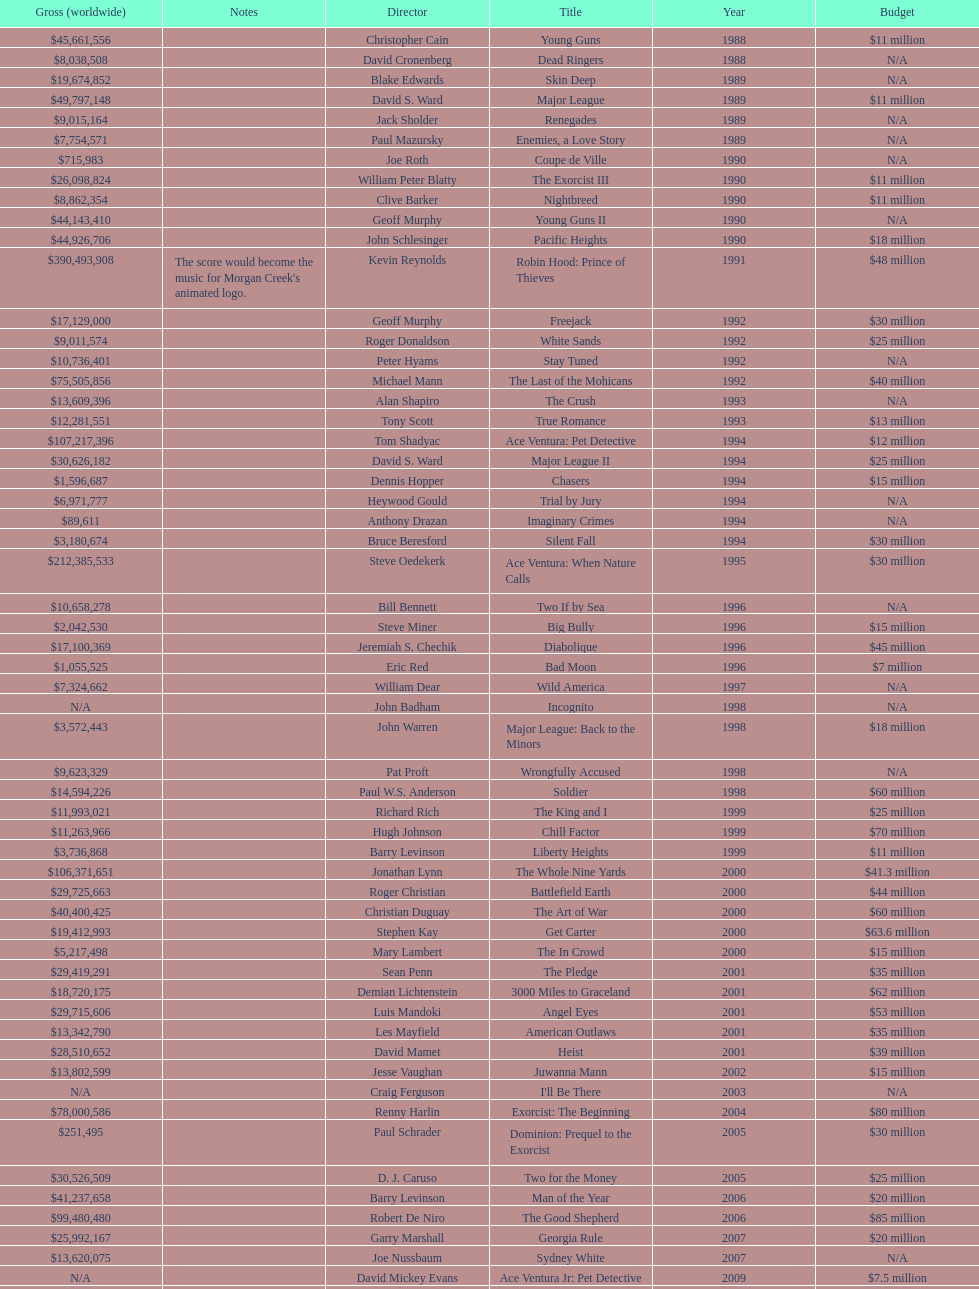Would you be able to parse every entry in this table? {'header': ['Gross (worldwide)', 'Notes', 'Director', 'Title', 'Year', 'Budget'], 'rows': [['$45,661,556', '', 'Christopher Cain', 'Young Guns', '1988', '$11 million'], ['$8,038,508', '', 'David Cronenberg', 'Dead Ringers', '1988', 'N/A'], ['$19,674,852', '', 'Blake Edwards', 'Skin Deep', '1989', 'N/A'], ['$49,797,148', '', 'David S. Ward', 'Major League', '1989', '$11 million'], ['$9,015,164', '', 'Jack Sholder', 'Renegades', '1989', 'N/A'], ['$7,754,571', '', 'Paul Mazursky', 'Enemies, a Love Story', '1989', 'N/A'], ['$715,983', '', 'Joe Roth', 'Coupe de Ville', '1990', 'N/A'], ['$26,098,824', '', 'William Peter Blatty', 'The Exorcist III', '1990', '$11 million'], ['$8,862,354', '', 'Clive Barker', 'Nightbreed', '1990', '$11 million'], ['$44,143,410', '', 'Geoff Murphy', 'Young Guns II', '1990', 'N/A'], ['$44,926,706', '', 'John Schlesinger', 'Pacific Heights', '1990', '$18 million'], ['$390,493,908', "The score would become the music for Morgan Creek's animated logo.", 'Kevin Reynolds', 'Robin Hood: Prince of Thieves', '1991', '$48 million'], ['$17,129,000', '', 'Geoff Murphy', 'Freejack', '1992', '$30 million'], ['$9,011,574', '', 'Roger Donaldson', 'White Sands', '1992', '$25 million'], ['$10,736,401', '', 'Peter Hyams', 'Stay Tuned', '1992', 'N/A'], ['$75,505,856', '', 'Michael Mann', 'The Last of the Mohicans', '1992', '$40 million'], ['$13,609,396', '', 'Alan Shapiro', 'The Crush', '1993', 'N/A'], ['$12,281,551', '', 'Tony Scott', 'True Romance', '1993', '$13 million'], ['$107,217,396', '', 'Tom Shadyac', 'Ace Ventura: Pet Detective', '1994', '$12 million'], ['$30,626,182', '', 'David S. Ward', 'Major League II', '1994', '$25 million'], ['$1,596,687', '', 'Dennis Hopper', 'Chasers', '1994', '$15 million'], ['$6,971,777', '', 'Heywood Gould', 'Trial by Jury', '1994', 'N/A'], ['$89,611', '', 'Anthony Drazan', 'Imaginary Crimes', '1994', 'N/A'], ['$3,180,674', '', 'Bruce Beresford', 'Silent Fall', '1994', '$30 million'], ['$212,385,533', '', 'Steve Oedekerk', 'Ace Ventura: When Nature Calls', '1995', '$30 million'], ['$10,658,278', '', 'Bill Bennett', 'Two If by Sea', '1996', 'N/A'], ['$2,042,530', '', 'Steve Miner', 'Big Bully', '1996', '$15 million'], ['$17,100,369', '', 'Jeremiah S. Chechik', 'Diabolique', '1996', '$45 million'], ['$1,055,525', '', 'Eric Red', 'Bad Moon', '1996', '$7 million'], ['$7,324,662', '', 'William Dear', 'Wild America', '1997', 'N/A'], ['N/A', '', 'John Badham', 'Incognito', '1998', 'N/A'], ['$3,572,443', '', 'John Warren', 'Major League: Back to the Minors', '1998', '$18 million'], ['$9,623,329', '', 'Pat Proft', 'Wrongfully Accused', '1998', 'N/A'], ['$14,594,226', '', 'Paul W.S. Anderson', 'Soldier', '1998', '$60 million'], ['$11,993,021', '', 'Richard Rich', 'The King and I', '1999', '$25 million'], ['$11,263,966', '', 'Hugh Johnson', 'Chill Factor', '1999', '$70 million'], ['$3,736,868', '', 'Barry Levinson', 'Liberty Heights', '1999', '$11 million'], ['$106,371,651', '', 'Jonathan Lynn', 'The Whole Nine Yards', '2000', '$41.3 million'], ['$29,725,663', '', 'Roger Christian', 'Battlefield Earth', '2000', '$44 million'], ['$40,400,425', '', 'Christian Duguay', 'The Art of War', '2000', '$60 million'], ['$19,412,993', '', 'Stephen Kay', 'Get Carter', '2000', '$63.6 million'], ['$5,217,498', '', 'Mary Lambert', 'The In Crowd', '2000', '$15 million'], ['$29,419,291', '', 'Sean Penn', 'The Pledge', '2001', '$35 million'], ['$18,720,175', '', 'Demian Lichtenstein', '3000 Miles to Graceland', '2001', '$62 million'], ['$29,715,606', '', 'Luis Mandoki', 'Angel Eyes', '2001', '$53 million'], ['$13,342,790', '', 'Les Mayfield', 'American Outlaws', '2001', '$35 million'], ['$28,510,652', '', 'David Mamet', 'Heist', '2001', '$39 million'], ['$13,802,599', '', 'Jesse Vaughan', 'Juwanna Mann', '2002', '$15 million'], ['N/A', '', 'Craig Ferguson', "I'll Be There", '2003', 'N/A'], ['$78,000,586', '', 'Renny Harlin', 'Exorcist: The Beginning', '2004', '$80 million'], ['$251,495', '', 'Paul Schrader', 'Dominion: Prequel to the Exorcist', '2005', '$30 million'], ['$30,526,509', '', 'D. J. Caruso', 'Two for the Money', '2005', '$25 million'], ['$41,237,658', '', 'Barry Levinson', 'Man of the Year', '2006', '$20 million'], ['$99,480,480', '', 'Robert De Niro', 'The Good Shepherd', '2006', '$85 million'], ['$25,992,167', '', 'Garry Marshall', 'Georgia Rule', '2007', '$20 million'], ['$13,620,075', '', 'Joe Nussbaum', 'Sydney White', '2007', 'N/A'], ['N/A', '', 'David Mickey Evans', 'Ace Ventura Jr: Pet Detective', '2009', '$7.5 million'], ['$38,502,340', '', 'Jim Sheridan', 'Dream House', '2011', '$50 million'], ['$27,428,670', '', 'Matthijs van Heijningen Jr.', 'The Thing', '2011', '$38 million'], ['', '', 'Antoine Fuqua', 'Tupac', '2014', '$45 million']]} What movie came out after bad moon? Wild America. 